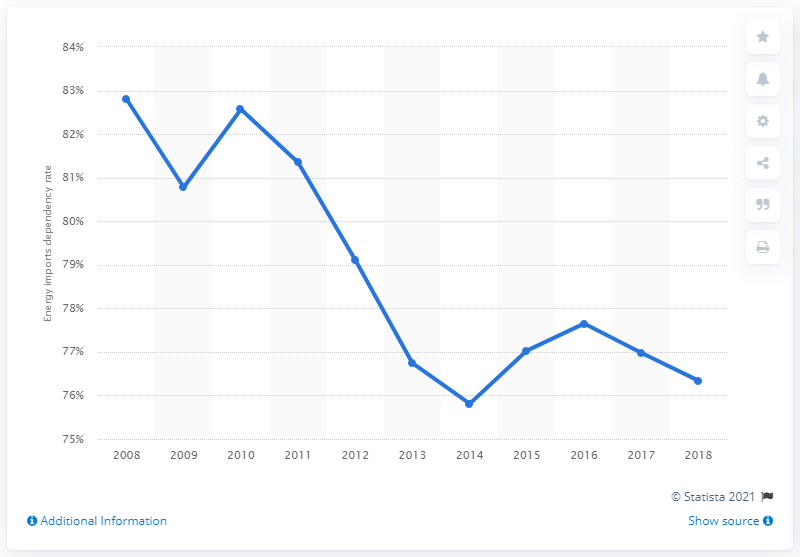List a handful of essential elements in this visual. In 2008, Italy's peak dependency rate on energy imports was 82.57%. 